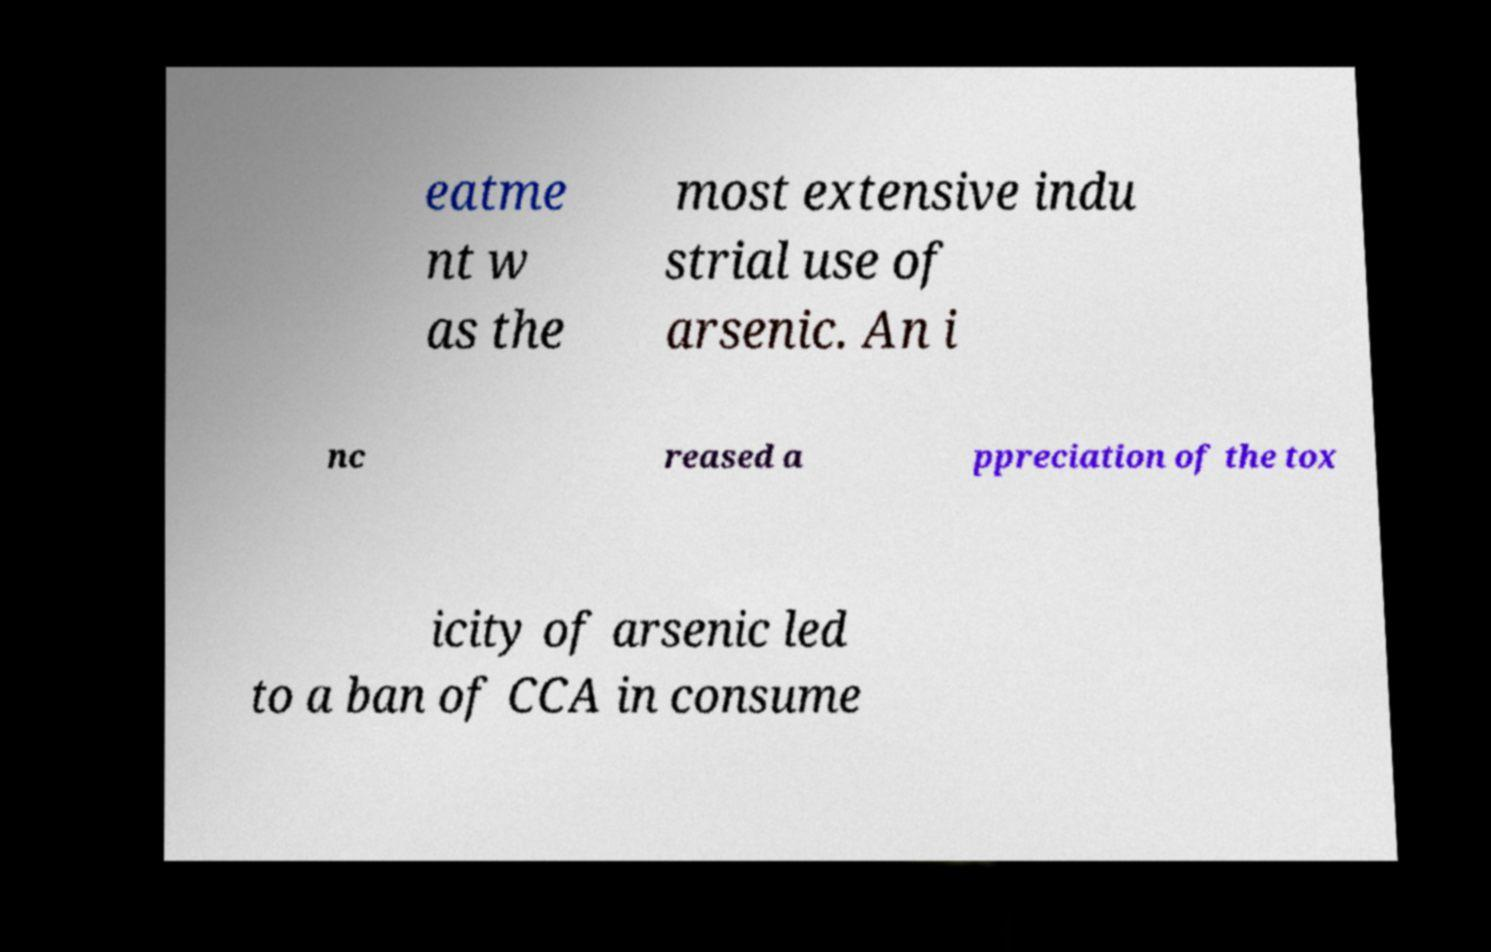Could you assist in decoding the text presented in this image and type it out clearly? eatme nt w as the most extensive indu strial use of arsenic. An i nc reased a ppreciation of the tox icity of arsenic led to a ban of CCA in consume 